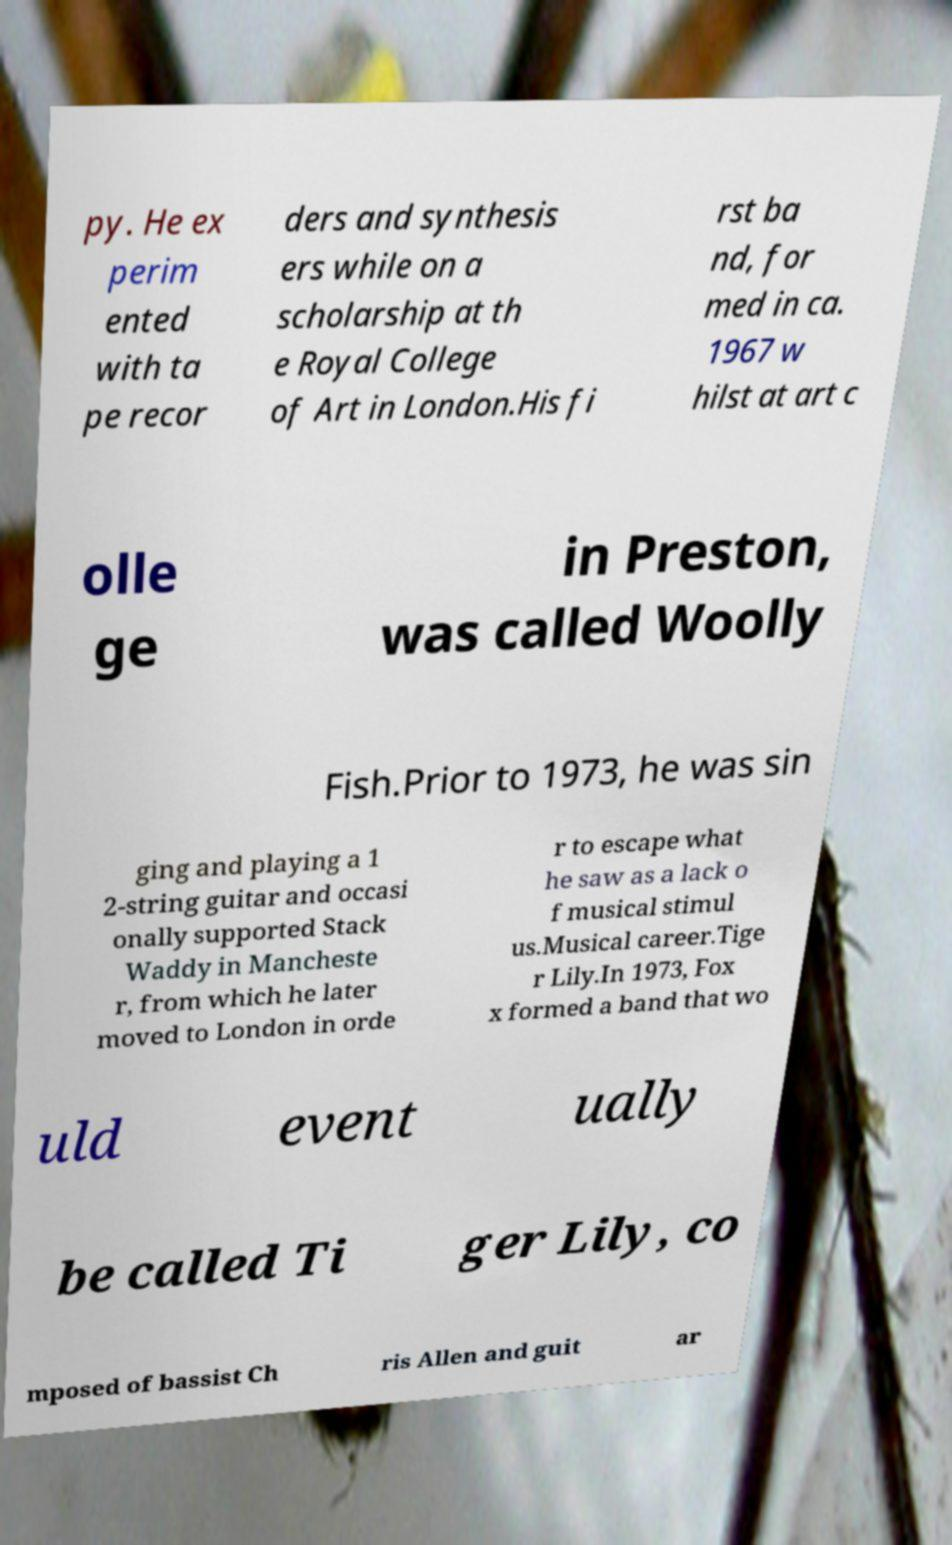Can you accurately transcribe the text from the provided image for me? py. He ex perim ented with ta pe recor ders and synthesis ers while on a scholarship at th e Royal College of Art in London.His fi rst ba nd, for med in ca. 1967 w hilst at art c olle ge in Preston, was called Woolly Fish.Prior to 1973, he was sin ging and playing a 1 2-string guitar and occasi onally supported Stack Waddy in Mancheste r, from which he later moved to London in orde r to escape what he saw as a lack o f musical stimul us.Musical career.Tige r Lily.In 1973, Fox x formed a band that wo uld event ually be called Ti ger Lily, co mposed of bassist Ch ris Allen and guit ar 